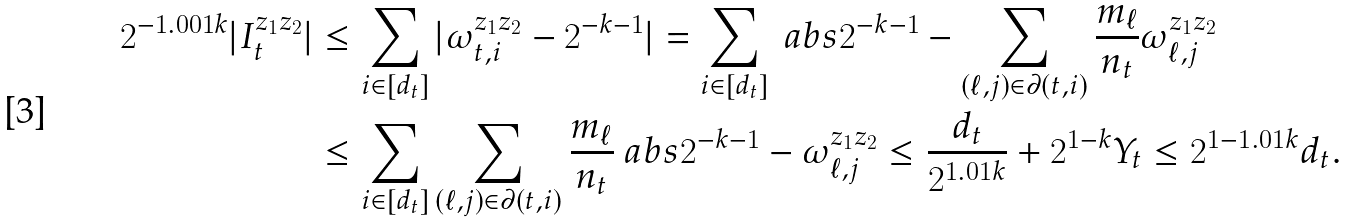Convert formula to latex. <formula><loc_0><loc_0><loc_500><loc_500>2 ^ { - 1 . 0 0 1 k } | I _ { t } ^ { z _ { 1 } z _ { 2 } } | & \leq \sum _ { i \in [ d _ { t } ] } | \omega _ { t , i } ^ { z _ { 1 } z _ { 2 } } - 2 ^ { - k - 1 } | = \sum _ { i \in [ d _ { t } ] } \ a b s { 2 ^ { - k - 1 } - \sum _ { ( \ell , j ) \in \partial ( t , i ) } \frac { m _ { \ell } } { n _ { t } } \omega _ { \ell , j } ^ { z _ { 1 } z _ { 2 } } } \\ & \leq \sum _ { i \in [ d _ { t } ] } \sum _ { ( \ell , j ) \in \partial ( t , i ) } \frac { m _ { \ell } } { n _ { t } } \ a b s { 2 ^ { - k - 1 } - \omega _ { \ell , j } ^ { z _ { 1 } z _ { 2 } } } \leq \frac { d _ { t } } { 2 ^ { 1 . 0 1 k } } + 2 ^ { 1 - k } Y _ { t } \leq 2 ^ { 1 - 1 . 0 1 k } d _ { t } .</formula> 